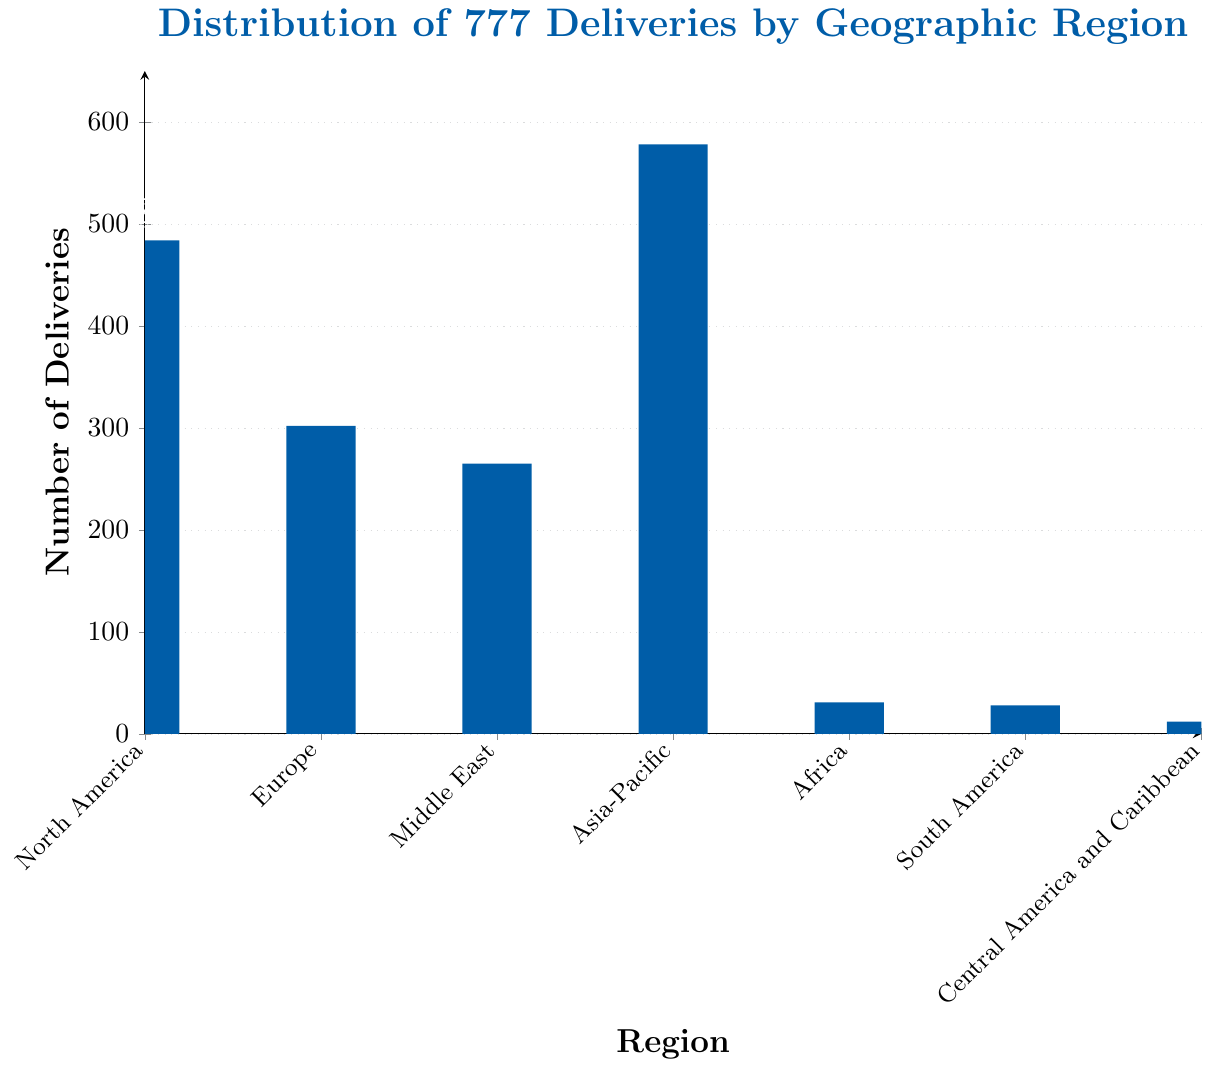Which region has the highest number of 777 deliveries? Look for the bar with the greatest height. The bar for Asia-Pacific is the tallest.
Answer: Asia-Pacific Which region has the smallest number of 777 deliveries? Look for the shortest bar. The bar for Central America and Caribbean is the shortest.
Answer: Central America and Caribbean How many more 777 deliveries does Asia-Pacific have compared to Europe? Subtract the number of deliveries in Europe from those in Asia-Pacific: 578 - 302 = 276
Answer: 276 What is the total number of 777 deliveries across all regions? Add the number of deliveries for each region: 484 + 302 + 265 + 578 + 31 + 28 + 12 = 1700
Answer: 1700 Which regions have more than 300 deliveries? Identify bars that exceed the 300 mark on the y-axis. North America, Asia-Pacific, and Europe all have more than 300 deliveries.
Answer: North America, Asia-Pacific, Europe Are there any regions with fewer than 50 deliveries? Look for bars that are close to the bottom of the y-axis. Africa, South America, and Central America and Caribbean each have fewer than 50 deliveries.
Answer: Africa, South America, Central America and Caribbean What percent of total deliveries does North America represent? Divide North America's deliveries by the total deliveries and multiply by 100: (484 / 1700) * 100 ≈ 28.47%
Answer: 28.47% How many regions have between 100 and 400 deliveries? Count the bars whose heights fall between 100 and 400. Europe and Middle East both fall in this range.
Answer: 2 What is the combined number of 777 deliveries for Africa, South America, and Central America and Caribbean? Add the number of deliveries for these regions: 31 + 28 + 12 = 71
Answer: 71 